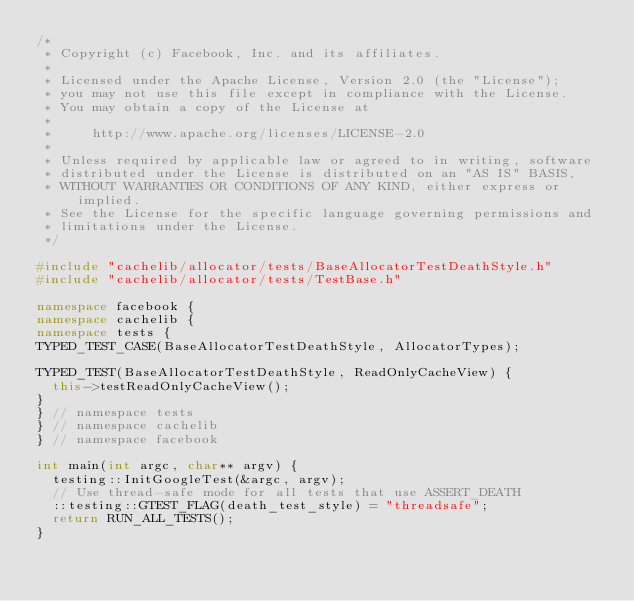Convert code to text. <code><loc_0><loc_0><loc_500><loc_500><_C++_>/*
 * Copyright (c) Facebook, Inc. and its affiliates.
 *
 * Licensed under the Apache License, Version 2.0 (the "License");
 * you may not use this file except in compliance with the License.
 * You may obtain a copy of the License at
 *
 *     http://www.apache.org/licenses/LICENSE-2.0
 *
 * Unless required by applicable law or agreed to in writing, software
 * distributed under the License is distributed on an "AS IS" BASIS,
 * WITHOUT WARRANTIES OR CONDITIONS OF ANY KIND, either express or implied.
 * See the License for the specific language governing permissions and
 * limitations under the License.
 */

#include "cachelib/allocator/tests/BaseAllocatorTestDeathStyle.h"
#include "cachelib/allocator/tests/TestBase.h"

namespace facebook {
namespace cachelib {
namespace tests {
TYPED_TEST_CASE(BaseAllocatorTestDeathStyle, AllocatorTypes);

TYPED_TEST(BaseAllocatorTestDeathStyle, ReadOnlyCacheView) {
  this->testReadOnlyCacheView();
}
} // namespace tests
} // namespace cachelib
} // namespace facebook

int main(int argc, char** argv) {
  testing::InitGoogleTest(&argc, argv);
  // Use thread-safe mode for all tests that use ASSERT_DEATH
  ::testing::GTEST_FLAG(death_test_style) = "threadsafe";
  return RUN_ALL_TESTS();
}
</code> 